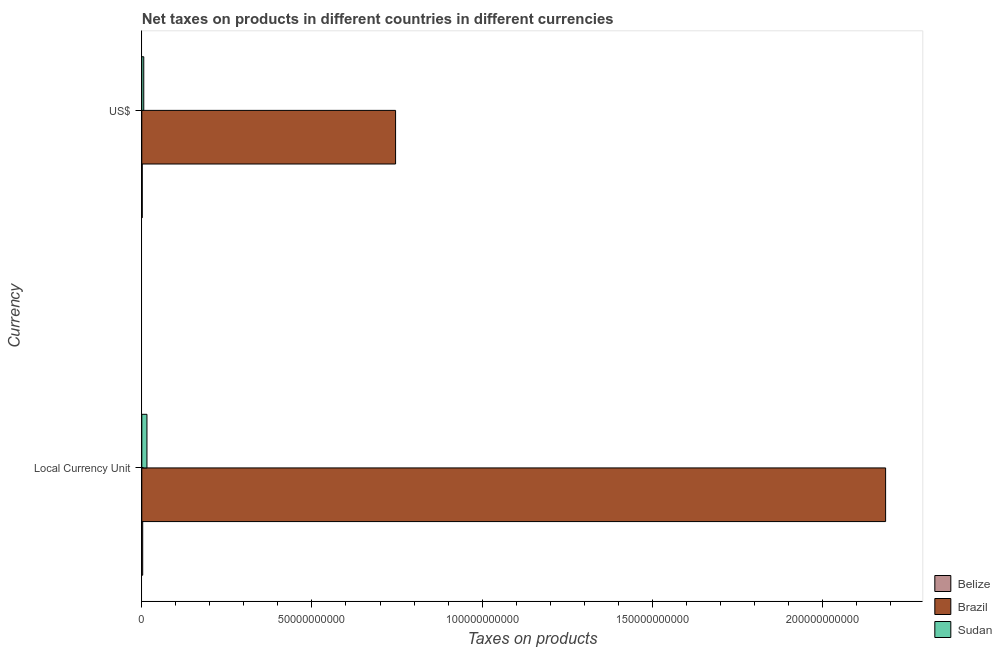Are the number of bars per tick equal to the number of legend labels?
Provide a short and direct response. Yes. Are the number of bars on each tick of the Y-axis equal?
Your answer should be compact. Yes. How many bars are there on the 2nd tick from the top?
Give a very brief answer. 3. How many bars are there on the 2nd tick from the bottom?
Keep it short and to the point. 3. What is the label of the 2nd group of bars from the top?
Provide a short and direct response. Local Currency Unit. What is the net taxes in constant 2005 us$ in Belize?
Offer a terse response. 2.64e+08. Across all countries, what is the maximum net taxes in us$?
Provide a short and direct response. 7.46e+1. Across all countries, what is the minimum net taxes in us$?
Make the answer very short. 1.32e+08. In which country was the net taxes in constant 2005 us$ minimum?
Offer a terse response. Belize. What is the total net taxes in us$ in the graph?
Offer a terse response. 7.53e+1. What is the difference between the net taxes in us$ in Belize and that in Sudan?
Ensure brevity in your answer.  -4.44e+08. What is the difference between the net taxes in us$ in Belize and the net taxes in constant 2005 us$ in Sudan?
Give a very brief answer. -1.38e+09. What is the average net taxes in us$ per country?
Keep it short and to the point. 2.51e+1. What is the difference between the net taxes in constant 2005 us$ and net taxes in us$ in Brazil?
Your response must be concise. 1.44e+11. What is the ratio of the net taxes in constant 2005 us$ in Brazil to that in Belize?
Give a very brief answer. 829.01. Is the net taxes in constant 2005 us$ in Brazil less than that in Belize?
Make the answer very short. No. What does the 3rd bar from the bottom in Local Currency Unit represents?
Your answer should be very brief. Sudan. Are the values on the major ticks of X-axis written in scientific E-notation?
Ensure brevity in your answer.  No. Where does the legend appear in the graph?
Offer a very short reply. Bottom right. How many legend labels are there?
Offer a very short reply. 3. What is the title of the graph?
Offer a terse response. Net taxes on products in different countries in different currencies. Does "Korea (Democratic)" appear as one of the legend labels in the graph?
Offer a terse response. No. What is the label or title of the X-axis?
Your answer should be very brief. Taxes on products. What is the label or title of the Y-axis?
Provide a short and direct response. Currency. What is the Taxes on products in Belize in Local Currency Unit?
Your answer should be very brief. 2.64e+08. What is the Taxes on products in Brazil in Local Currency Unit?
Ensure brevity in your answer.  2.19e+11. What is the Taxes on products of Sudan in Local Currency Unit?
Your response must be concise. 1.52e+09. What is the Taxes on products in Belize in US$?
Offer a very short reply. 1.32e+08. What is the Taxes on products of Brazil in US$?
Give a very brief answer. 7.46e+1. What is the Taxes on products in Sudan in US$?
Keep it short and to the point. 5.76e+08. Across all Currency, what is the maximum Taxes on products of Belize?
Offer a very short reply. 2.64e+08. Across all Currency, what is the maximum Taxes on products in Brazil?
Offer a very short reply. 2.19e+11. Across all Currency, what is the maximum Taxes on products in Sudan?
Ensure brevity in your answer.  1.52e+09. Across all Currency, what is the minimum Taxes on products in Belize?
Give a very brief answer. 1.32e+08. Across all Currency, what is the minimum Taxes on products of Brazil?
Offer a very short reply. 7.46e+1. Across all Currency, what is the minimum Taxes on products of Sudan?
Your answer should be compact. 5.76e+08. What is the total Taxes on products of Belize in the graph?
Your answer should be very brief. 3.95e+08. What is the total Taxes on products in Brazil in the graph?
Keep it short and to the point. 2.93e+11. What is the total Taxes on products in Sudan in the graph?
Keep it short and to the point. 2.09e+09. What is the difference between the Taxes on products in Belize in Local Currency Unit and that in US$?
Keep it short and to the point. 1.32e+08. What is the difference between the Taxes on products of Brazil in Local Currency Unit and that in US$?
Give a very brief answer. 1.44e+11. What is the difference between the Taxes on products in Sudan in Local Currency Unit and that in US$?
Provide a succinct answer. 9.40e+08. What is the difference between the Taxes on products in Belize in Local Currency Unit and the Taxes on products in Brazil in US$?
Ensure brevity in your answer.  -7.43e+1. What is the difference between the Taxes on products of Belize in Local Currency Unit and the Taxes on products of Sudan in US$?
Your answer should be compact. -3.12e+08. What is the difference between the Taxes on products of Brazil in Local Currency Unit and the Taxes on products of Sudan in US$?
Provide a succinct answer. 2.18e+11. What is the average Taxes on products in Belize per Currency?
Make the answer very short. 1.98e+08. What is the average Taxes on products of Brazil per Currency?
Your answer should be compact. 1.47e+11. What is the average Taxes on products in Sudan per Currency?
Provide a short and direct response. 1.05e+09. What is the difference between the Taxes on products in Belize and Taxes on products in Brazil in Local Currency Unit?
Provide a succinct answer. -2.18e+11. What is the difference between the Taxes on products in Belize and Taxes on products in Sudan in Local Currency Unit?
Offer a terse response. -1.25e+09. What is the difference between the Taxes on products of Brazil and Taxes on products of Sudan in Local Currency Unit?
Provide a succinct answer. 2.17e+11. What is the difference between the Taxes on products in Belize and Taxes on products in Brazil in US$?
Offer a terse response. -7.44e+1. What is the difference between the Taxes on products of Belize and Taxes on products of Sudan in US$?
Keep it short and to the point. -4.44e+08. What is the difference between the Taxes on products in Brazil and Taxes on products in Sudan in US$?
Give a very brief answer. 7.40e+1. What is the ratio of the Taxes on products of Belize in Local Currency Unit to that in US$?
Give a very brief answer. 2. What is the ratio of the Taxes on products in Brazil in Local Currency Unit to that in US$?
Provide a succinct answer. 2.93. What is the ratio of the Taxes on products of Sudan in Local Currency Unit to that in US$?
Your answer should be very brief. 2.63. What is the difference between the highest and the second highest Taxes on products of Belize?
Your answer should be very brief. 1.32e+08. What is the difference between the highest and the second highest Taxes on products in Brazil?
Ensure brevity in your answer.  1.44e+11. What is the difference between the highest and the second highest Taxes on products of Sudan?
Make the answer very short. 9.40e+08. What is the difference between the highest and the lowest Taxes on products of Belize?
Your response must be concise. 1.32e+08. What is the difference between the highest and the lowest Taxes on products of Brazil?
Your answer should be very brief. 1.44e+11. What is the difference between the highest and the lowest Taxes on products of Sudan?
Give a very brief answer. 9.40e+08. 